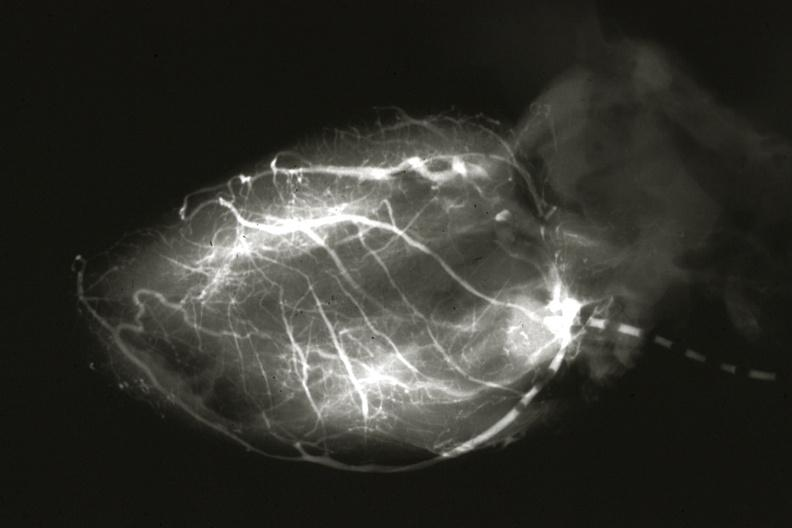where is this from?
Answer the question using a single word or phrase. Heart 